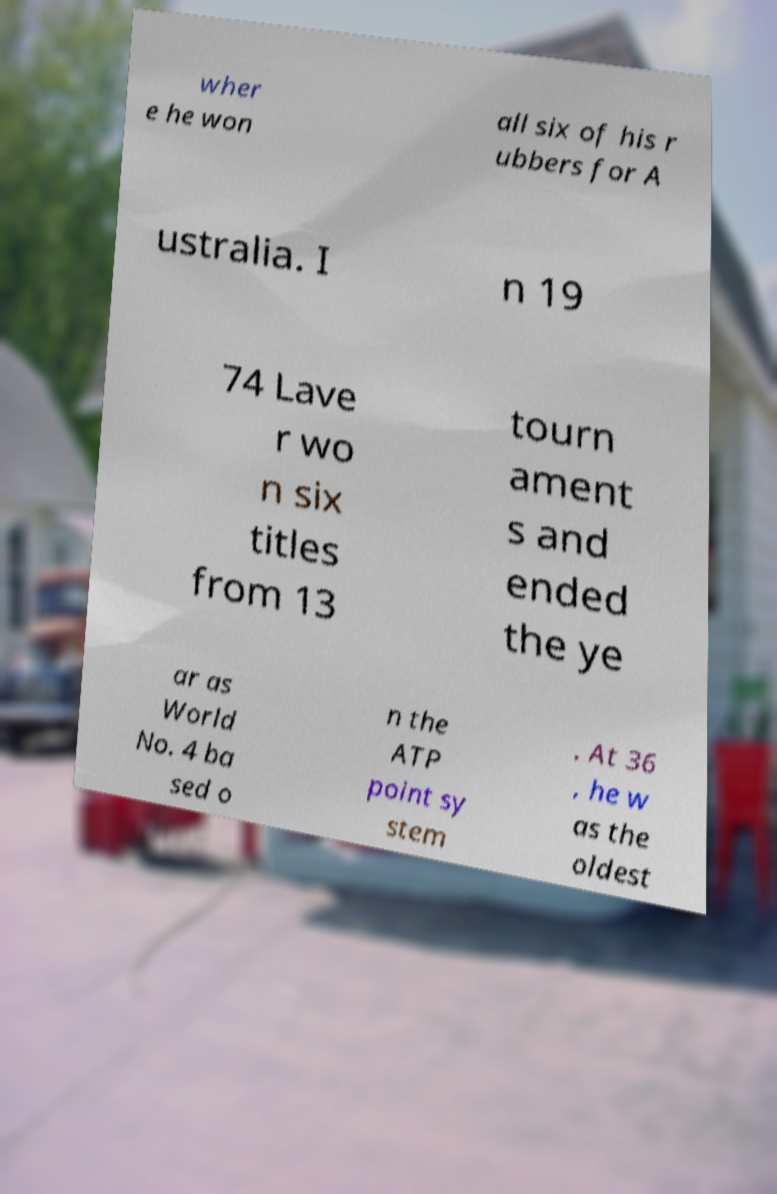Please read and relay the text visible in this image. What does it say? wher e he won all six of his r ubbers for A ustralia. I n 19 74 Lave r wo n six titles from 13 tourn ament s and ended the ye ar as World No. 4 ba sed o n the ATP point sy stem . At 36 , he w as the oldest 